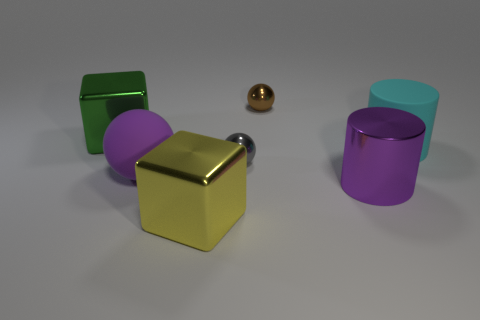There is a shiny cylinder that is the same size as the purple rubber object; what color is it? purple 